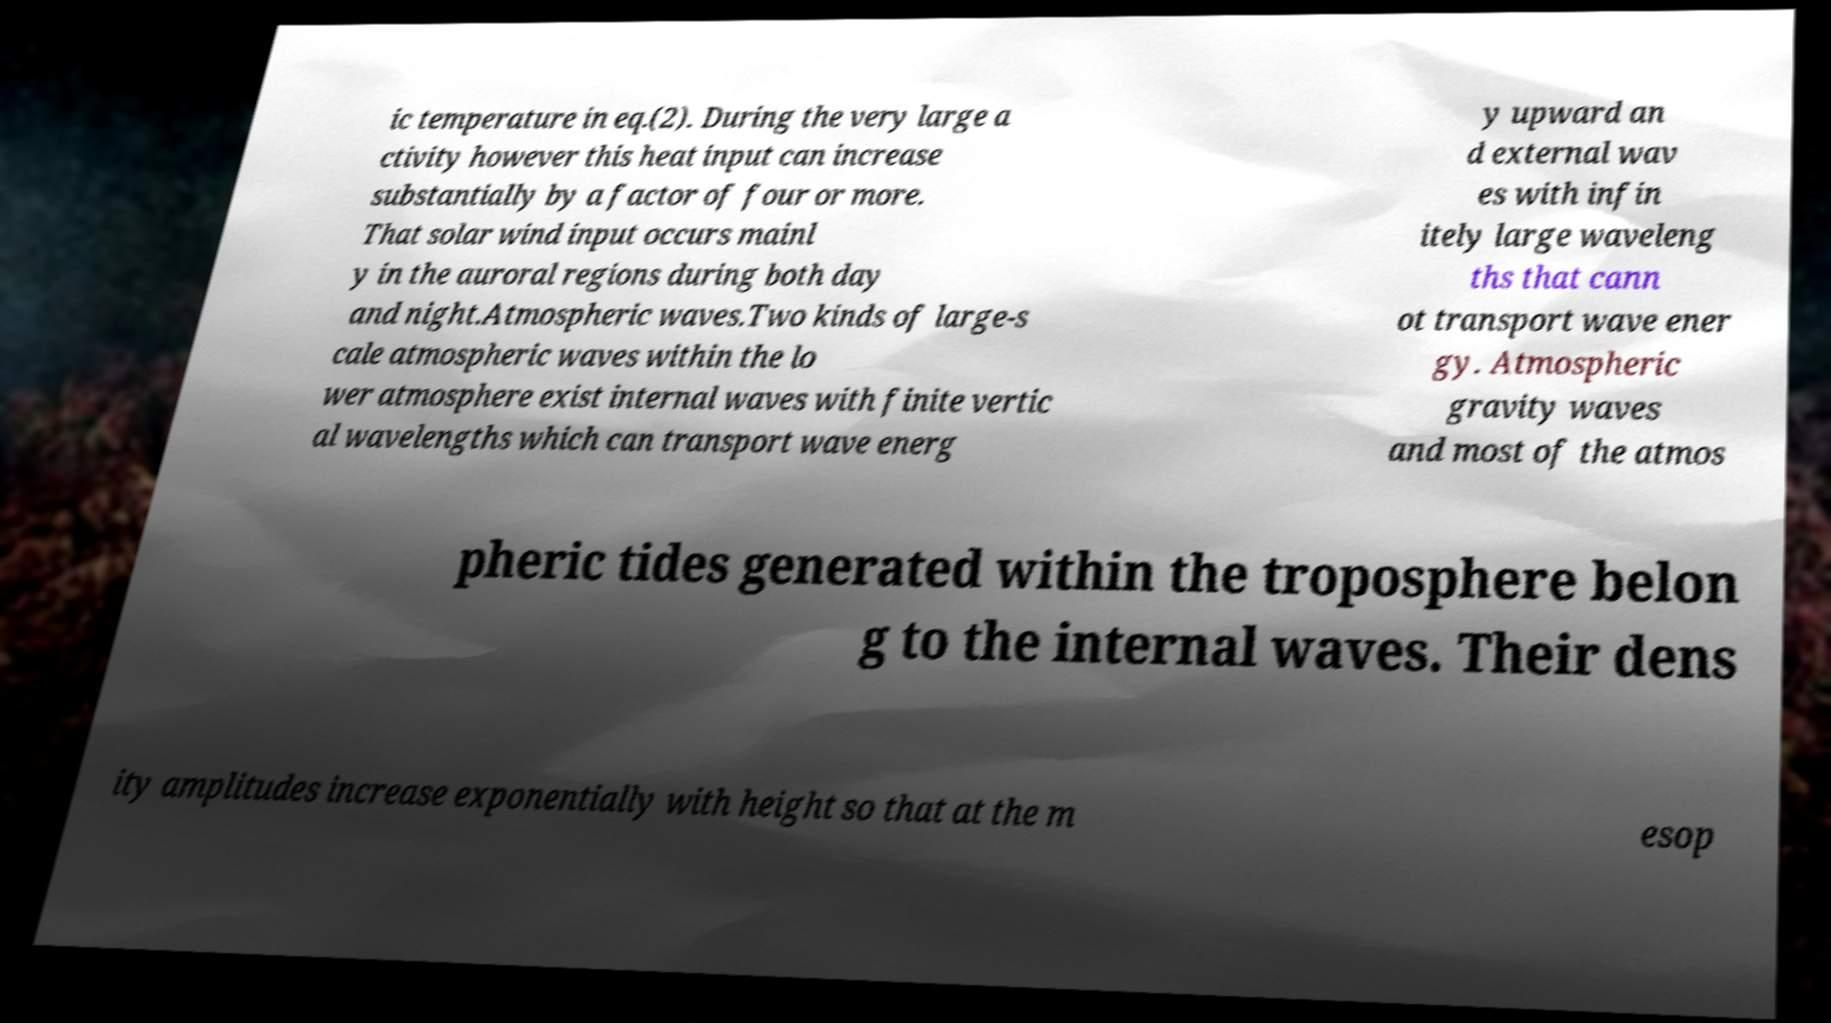Can you read and provide the text displayed in the image?This photo seems to have some interesting text. Can you extract and type it out for me? ic temperature in eq.(2). During the very large a ctivity however this heat input can increase substantially by a factor of four or more. That solar wind input occurs mainl y in the auroral regions during both day and night.Atmospheric waves.Two kinds of large-s cale atmospheric waves within the lo wer atmosphere exist internal waves with finite vertic al wavelengths which can transport wave energ y upward an d external wav es with infin itely large waveleng ths that cann ot transport wave ener gy. Atmospheric gravity waves and most of the atmos pheric tides generated within the troposphere belon g to the internal waves. Their dens ity amplitudes increase exponentially with height so that at the m esop 